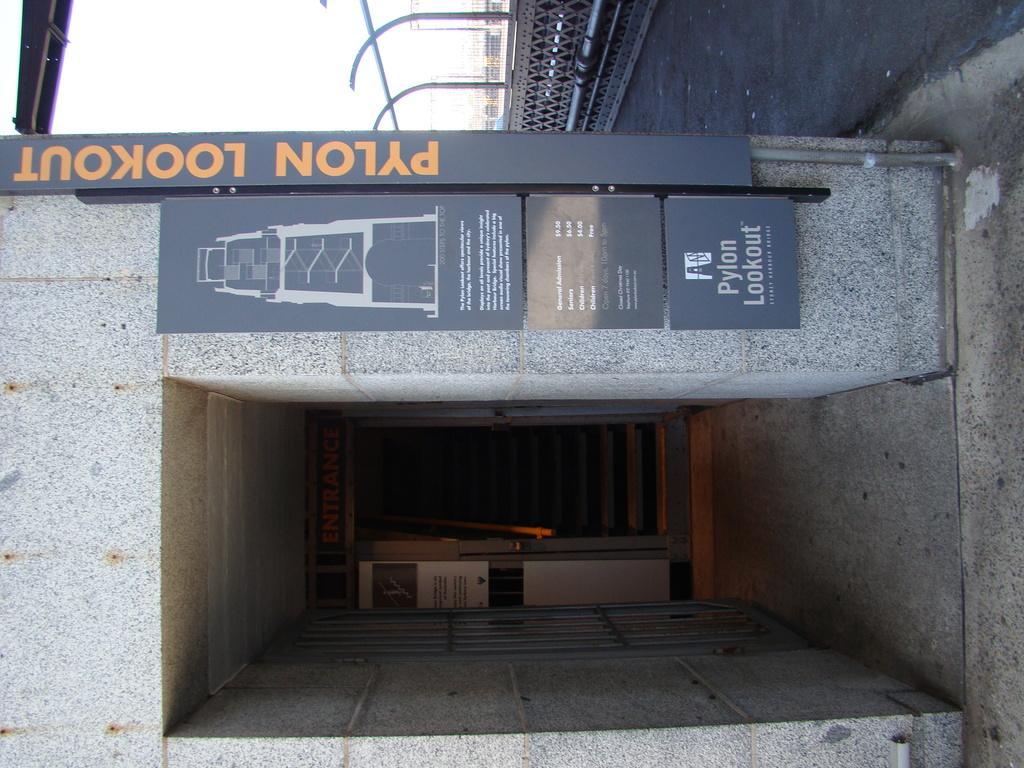Describe this image in one or two sentences. In this image we can see a elevator. There is a board with some text. To the right side of the image there is road. There are rods. At the top of the image there is sky. 